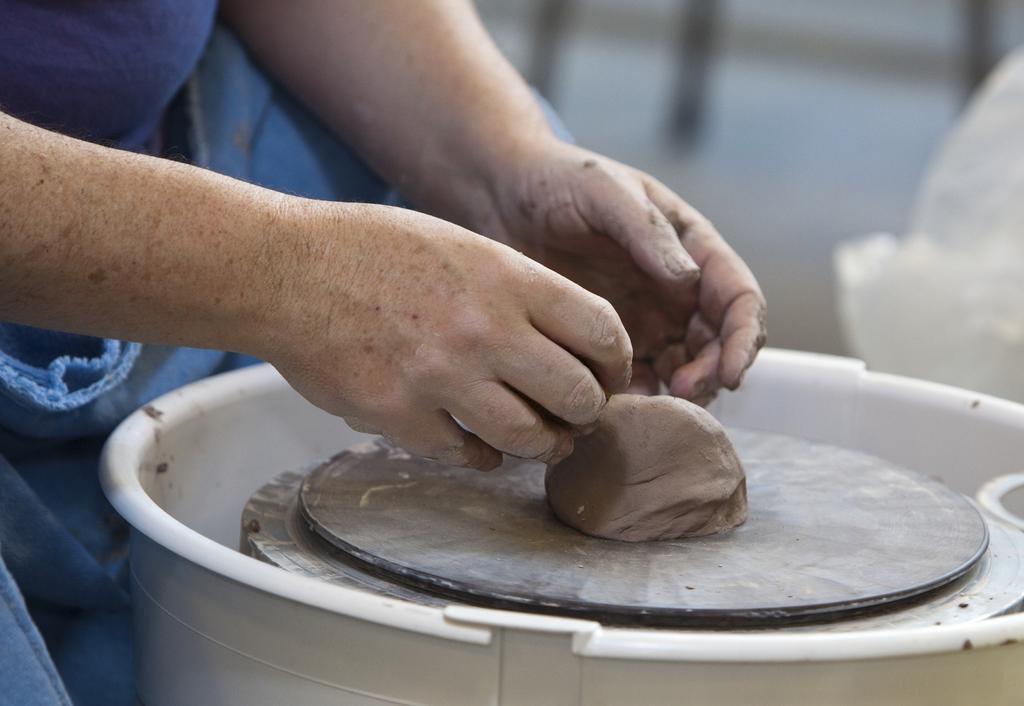In one or two sentences, can you explain what this image depicts? In this image we can see mud placed on the pottery wheel. On the left we can see a person. 